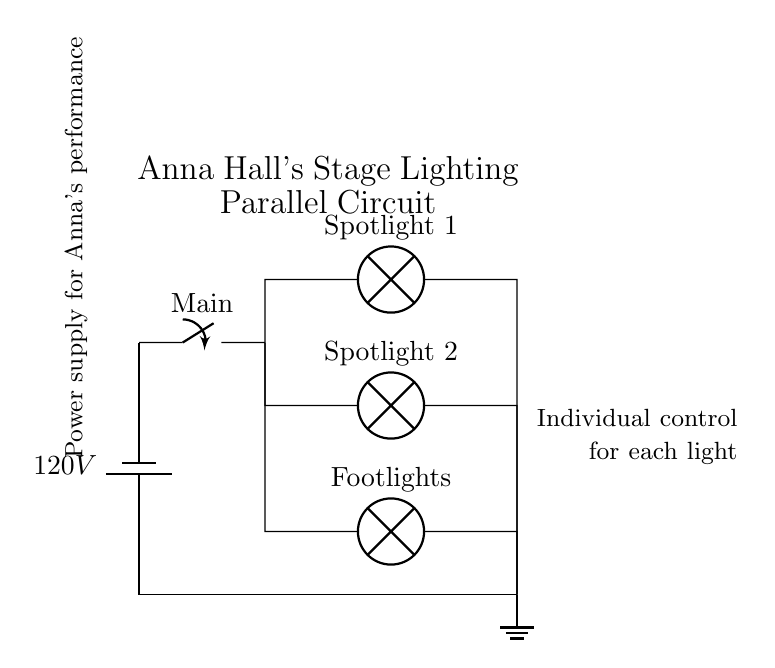What is the voltage in the circuit? The voltage is stated as 120V, which is indicated on the battery symbol at the top of the diagram.
Answer: 120V What type of switch is used in this circuit? The diagram shows a switch labeled "Main," which indicates it is a main switch, allowing control over the entire circuit.
Answer: Main switch How many types of lights are connected in parallel? There are three lamps connected in parallel: Spotlight 1, Spotlight 2, and Footlights. These can be observed as the branches stemming from the main circuit line.
Answer: Three lamps What is the significance of the parallel configuration in this circuit? The parallel configuration allows each lamp to operate independently. If one lamp fails, the others will continue to work, which is crucial for stage performances where consistent lighting is imperative.
Answer: Independent operation What does the ground symbol signify in this circuit? The ground symbol represents a common return path for the electrical circuit and is essential for safety, providing a path for excess current to avoid electric shock hazards.
Answer: Safety ground 